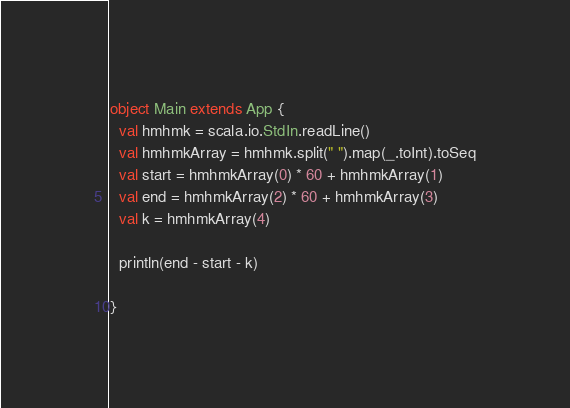Convert code to text. <code><loc_0><loc_0><loc_500><loc_500><_Scala_>object Main extends App {
  val hmhmk = scala.io.StdIn.readLine()
  val hmhmkArray = hmhmk.split(" ").map(_.toInt).toSeq
  val start = hmhmkArray(0) * 60 + hmhmkArray(1)
  val end = hmhmkArray(2) * 60 + hmhmkArray(3)
  val k = hmhmkArray(4)
 
  println(end - start - k)
 
}</code> 